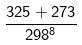Convert formula to latex. <formula><loc_0><loc_0><loc_500><loc_500>\frac { 3 2 5 + 2 7 3 } { 2 9 8 ^ { 8 } }</formula> 